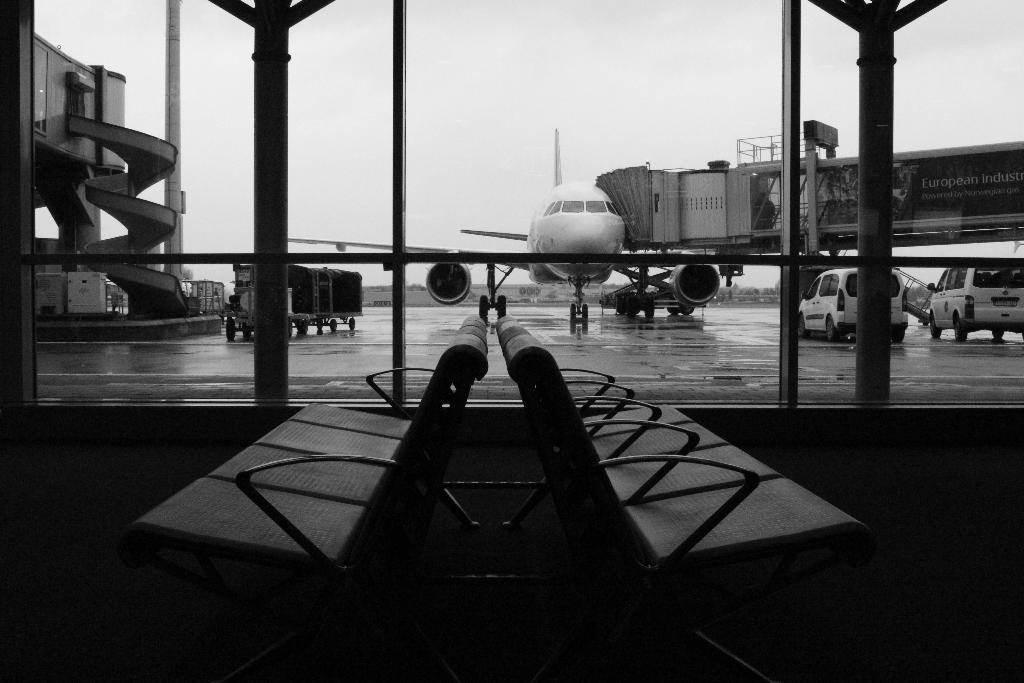What type of furniture is present in the image? There are chairs in the image. What type of material is used for the windows in the image? There are glass windows in the image. What mode of transportation is depicted in the image? There is an aircraft in the image. What other types of vehicles can be seen in the image? There are vehicles in the image. What is visible at the top of the image? The sky is visible at the top of the image. What type of root can be seen growing near the chairs in the image? There is no root present in the image; it features chairs, glass windows, an aircraft, vehicles, and a visible sky. What type of property is being sold in the image? There is no property being sold in the image; it focuses on chairs, glass windows, an aircraft, vehicles, and a visible sky. 